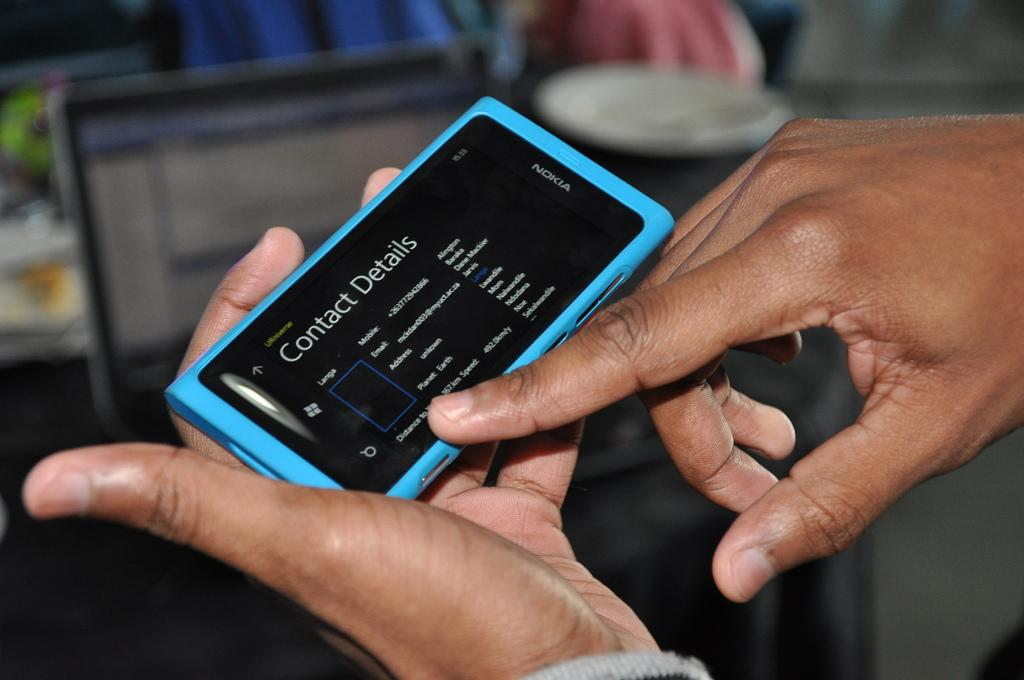<image>
Present a compact description of the photo's key features. A man holding a blue phone with the words contact details featuring at the top. 